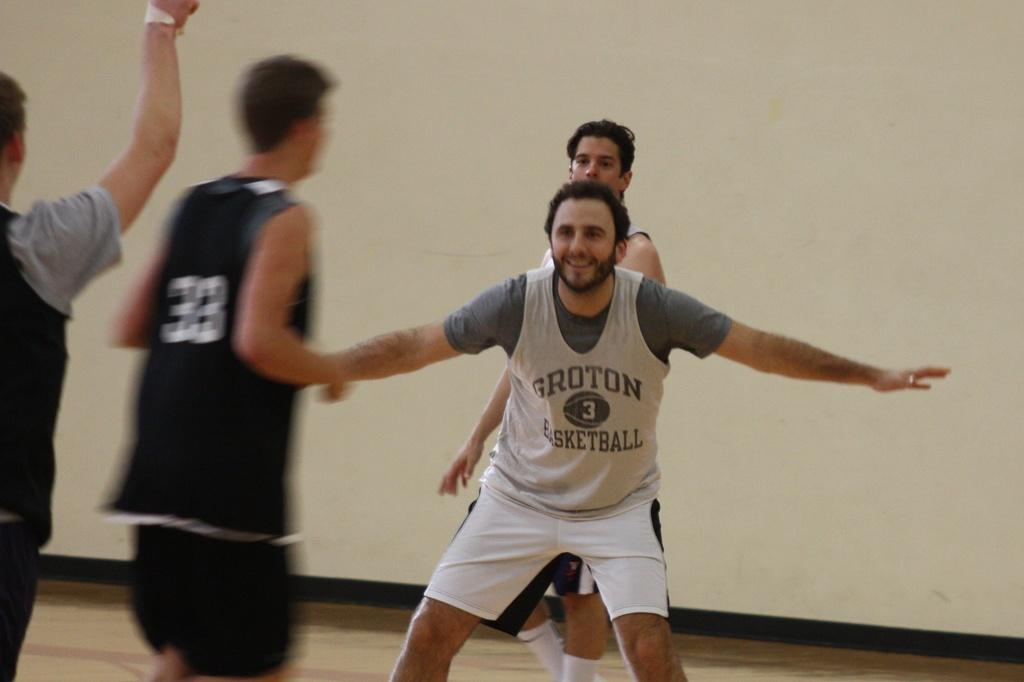<image>
Present a compact description of the photo's key features. A man from the Groton Basketball team standing with his arms out to the side. 